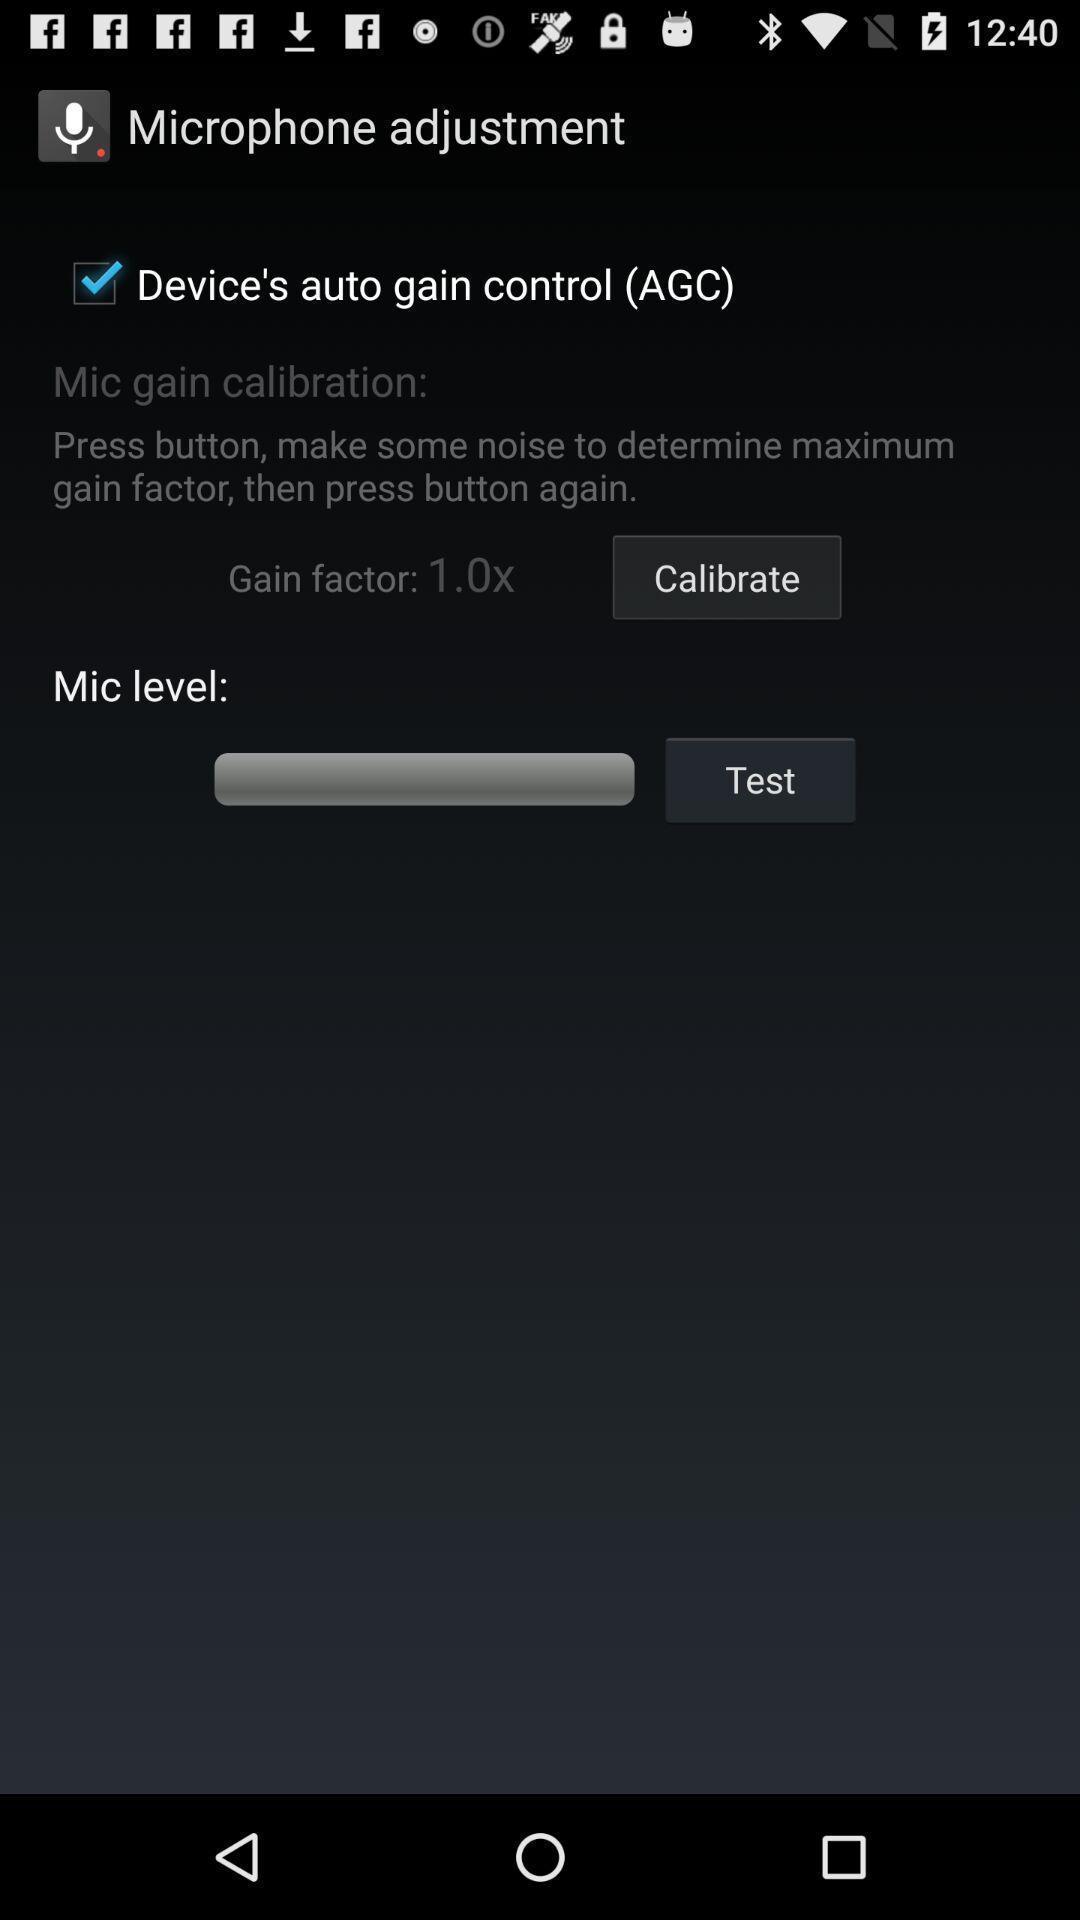Explain the elements present in this screenshot. Page showing different options. 